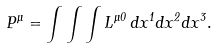<formula> <loc_0><loc_0><loc_500><loc_500>P ^ { \mu } = \int \int \int L ^ { \mu 0 } \, d x ^ { 1 } d x ^ { 2 } d x ^ { 3 } .</formula> 